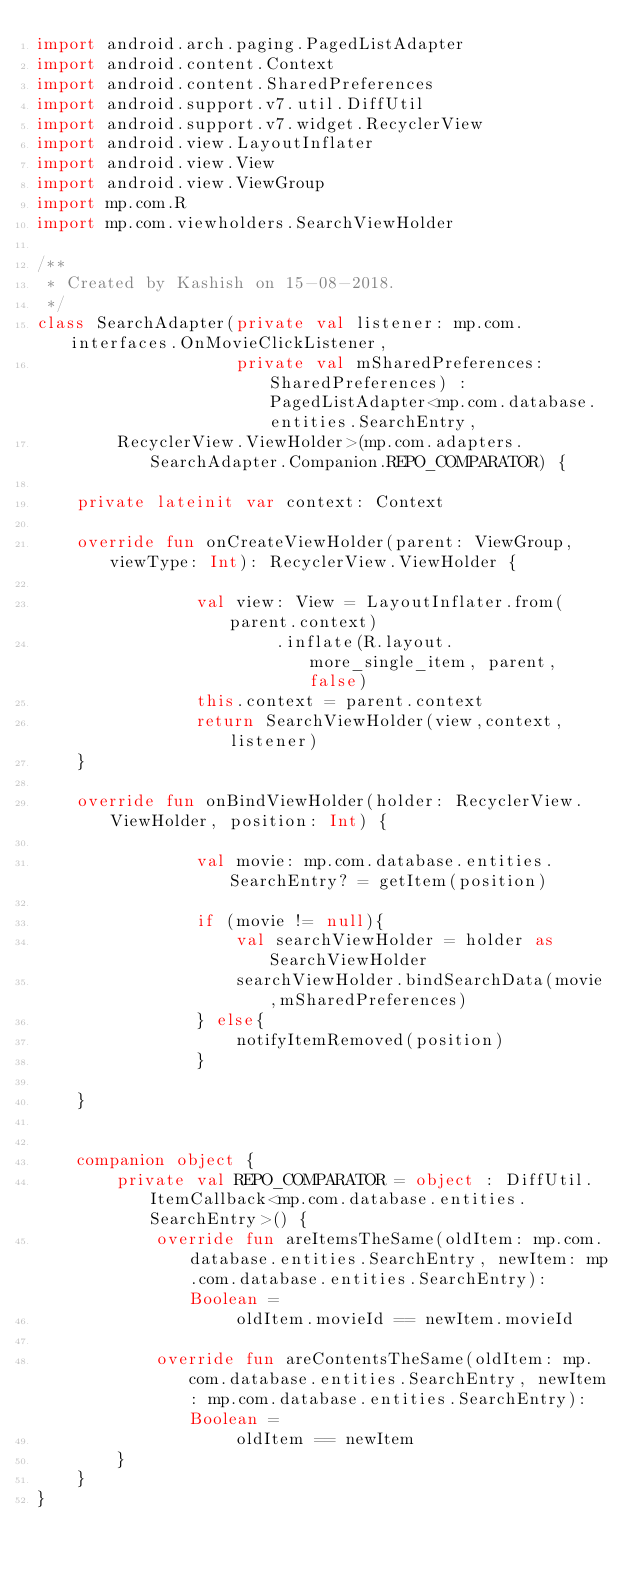Convert code to text. <code><loc_0><loc_0><loc_500><loc_500><_Kotlin_>import android.arch.paging.PagedListAdapter
import android.content.Context
import android.content.SharedPreferences
import android.support.v7.util.DiffUtil
import android.support.v7.widget.RecyclerView
import android.view.LayoutInflater
import android.view.View
import android.view.ViewGroup
import mp.com.R
import mp.com.viewholders.SearchViewHolder

/**
 * Created by Kashish on 15-08-2018.
 */
class SearchAdapter(private val listener: mp.com.interfaces.OnMovieClickListener,
                    private val mSharedPreferences: SharedPreferences) : PagedListAdapter<mp.com.database.entities.SearchEntry,
        RecyclerView.ViewHolder>(mp.com.adapters.SearchAdapter.Companion.REPO_COMPARATOR) {

    private lateinit var context: Context

    override fun onCreateViewHolder(parent: ViewGroup, viewType: Int): RecyclerView.ViewHolder {

                val view: View = LayoutInflater.from(parent.context)
                        .inflate(R.layout.more_single_item, parent, false)
                this.context = parent.context
                return SearchViewHolder(view,context,listener)
    }

    override fun onBindViewHolder(holder: RecyclerView.ViewHolder, position: Int) {

                val movie: mp.com.database.entities.SearchEntry? = getItem(position)

                if (movie != null){
                    val searchViewHolder = holder as SearchViewHolder
                    searchViewHolder.bindSearchData(movie,mSharedPreferences)
                } else{
                    notifyItemRemoved(position)
                }

    }


    companion object {
        private val REPO_COMPARATOR = object : DiffUtil.ItemCallback<mp.com.database.entities.SearchEntry>() {
            override fun areItemsTheSame(oldItem: mp.com.database.entities.SearchEntry, newItem: mp.com.database.entities.SearchEntry): Boolean =
                    oldItem.movieId == newItem.movieId

            override fun areContentsTheSame(oldItem: mp.com.database.entities.SearchEntry, newItem: mp.com.database.entities.SearchEntry): Boolean =
                    oldItem == newItem
        }
    }
}</code> 